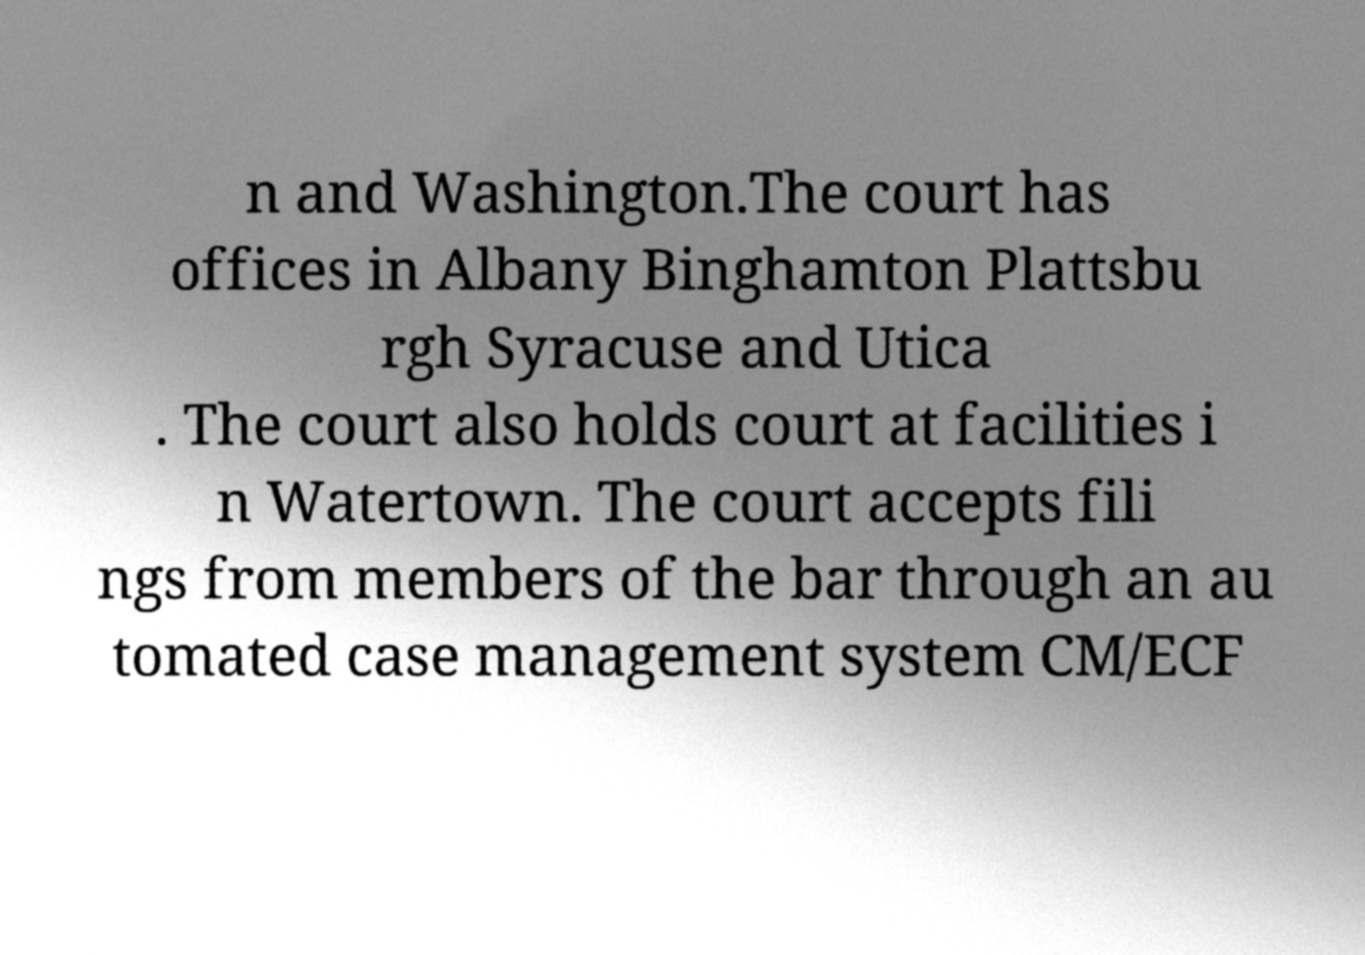I need the written content from this picture converted into text. Can you do that? n and Washington.The court has offices in Albany Binghamton Plattsbu rgh Syracuse and Utica . The court also holds court at facilities i n Watertown. The court accepts fili ngs from members of the bar through an au tomated case management system CM/ECF 